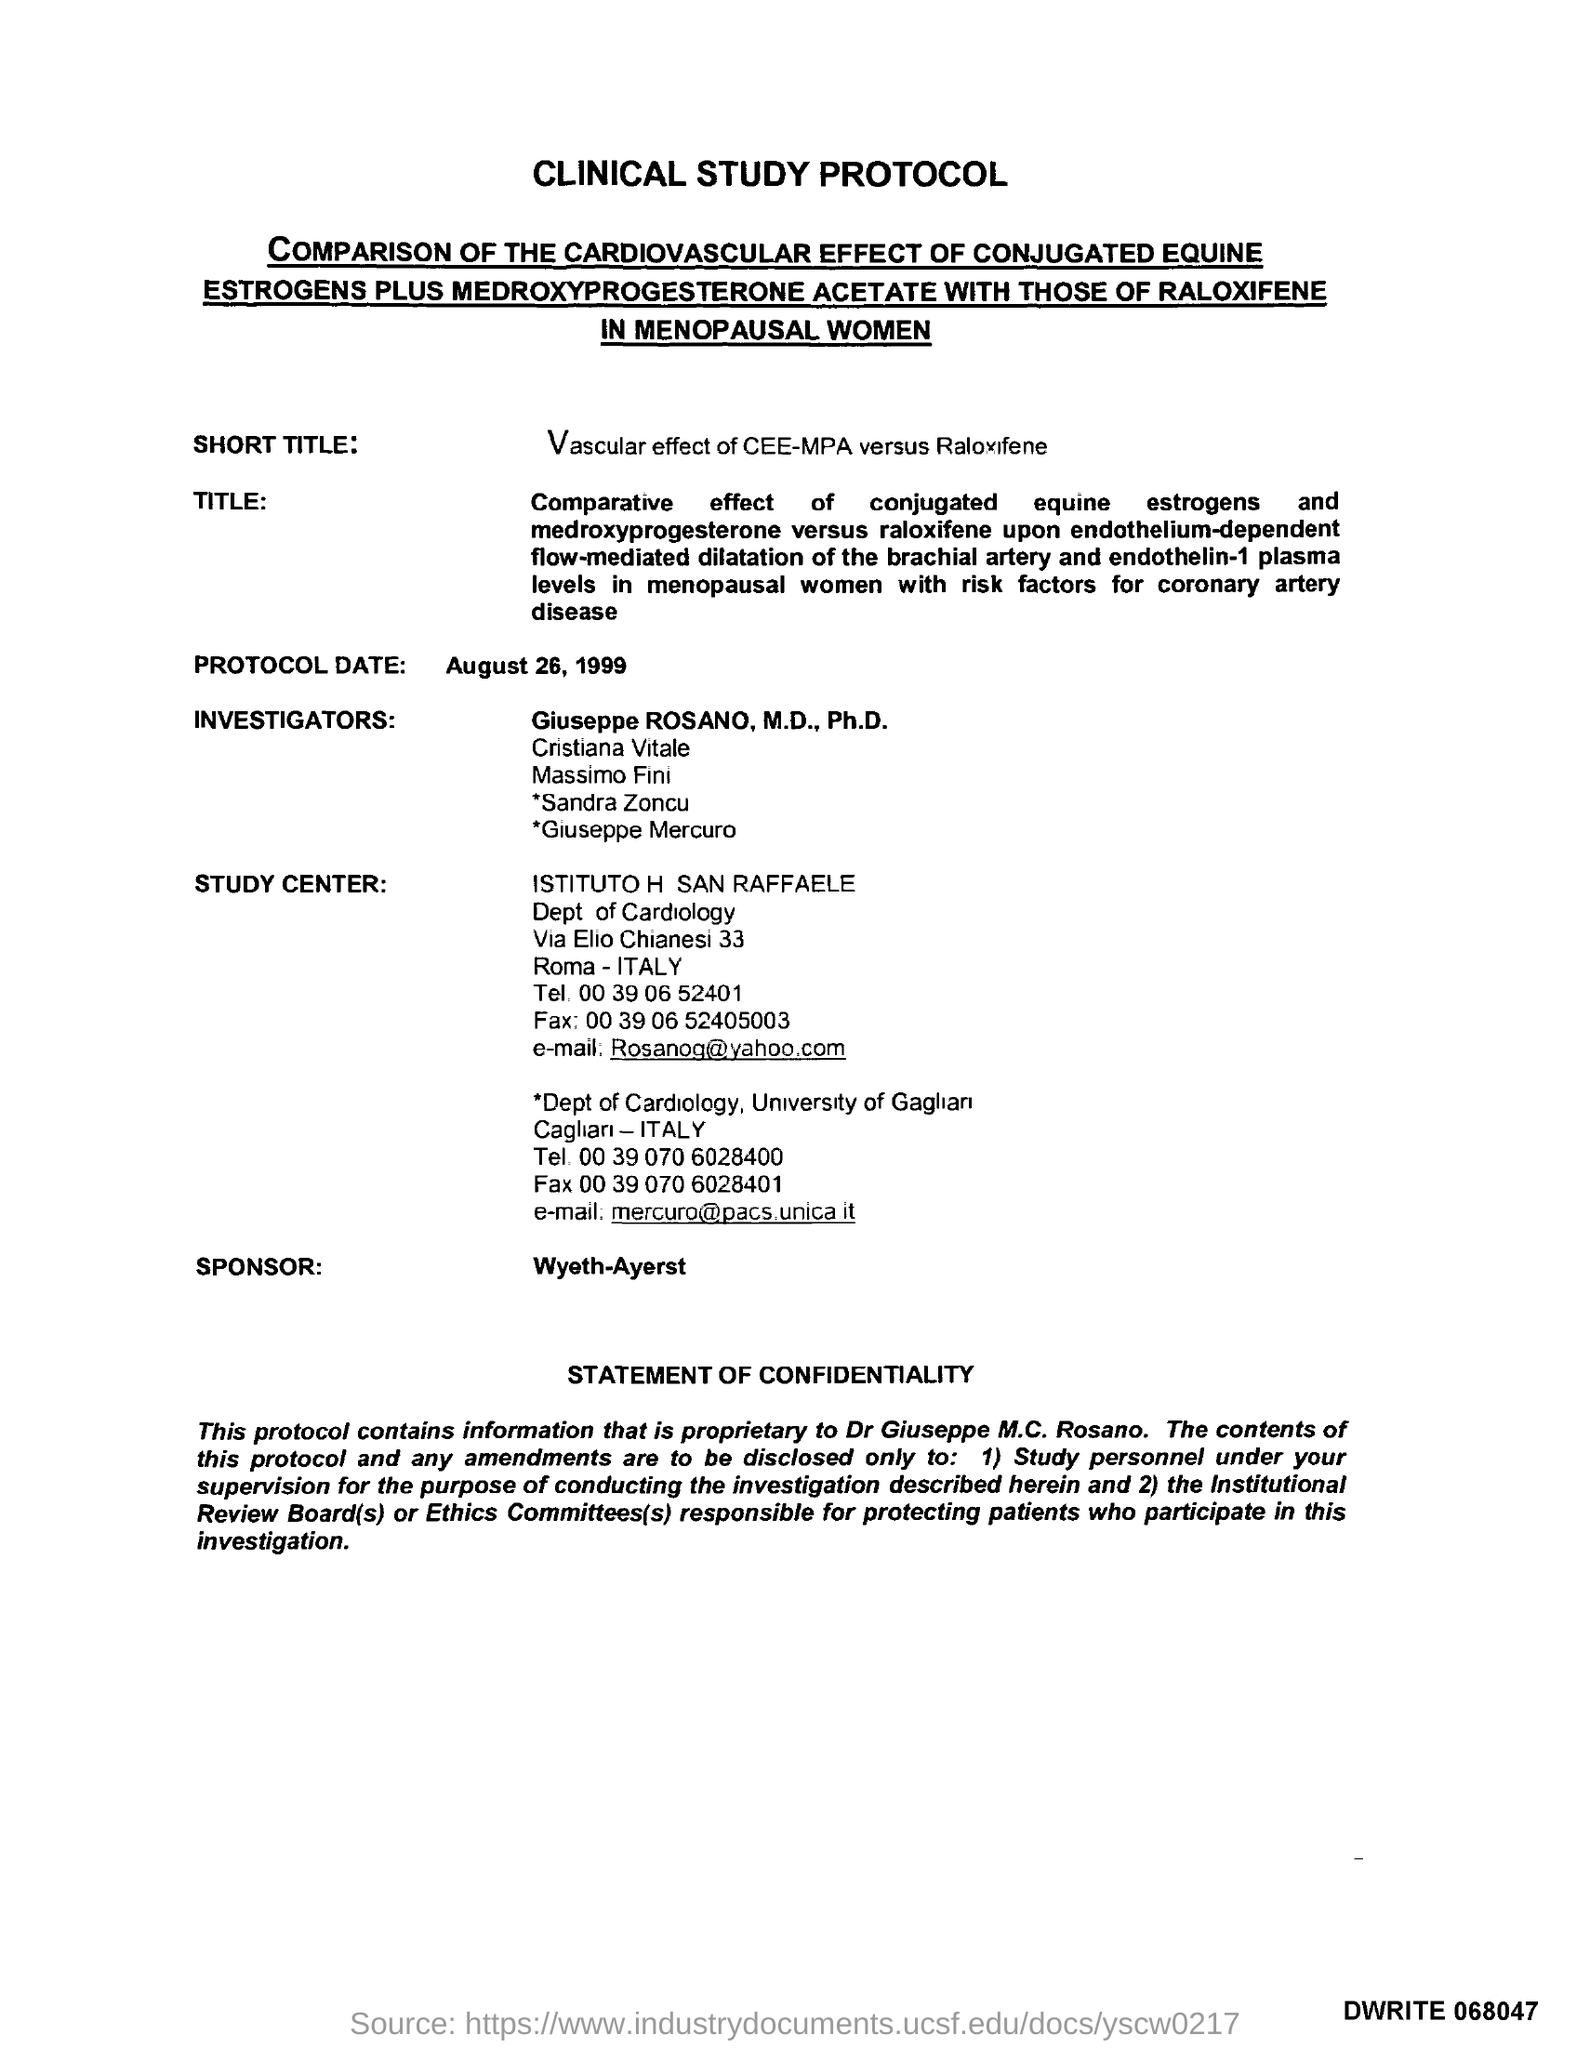Identify some key points in this picture. The Protocol Date is August 26, 1999. The email for the Department of Cardiology at the University of Gaglian is "[mercuro@pacs.unica.it](mailto:mercuro@pacs.unica.it)". The title of the document is 'Clinical Study Protocol'. Wyeth-Ayerst is the sponsor of this study. The email for ISTITUTO H SAN RAFFAELE is [rosanog@yahoo.com](mailto:rosanog@yahoo.com). 